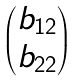Convert formula to latex. <formula><loc_0><loc_0><loc_500><loc_500>\begin{pmatrix} b _ { 1 2 } \\ b _ { 2 2 } \end{pmatrix}</formula> 